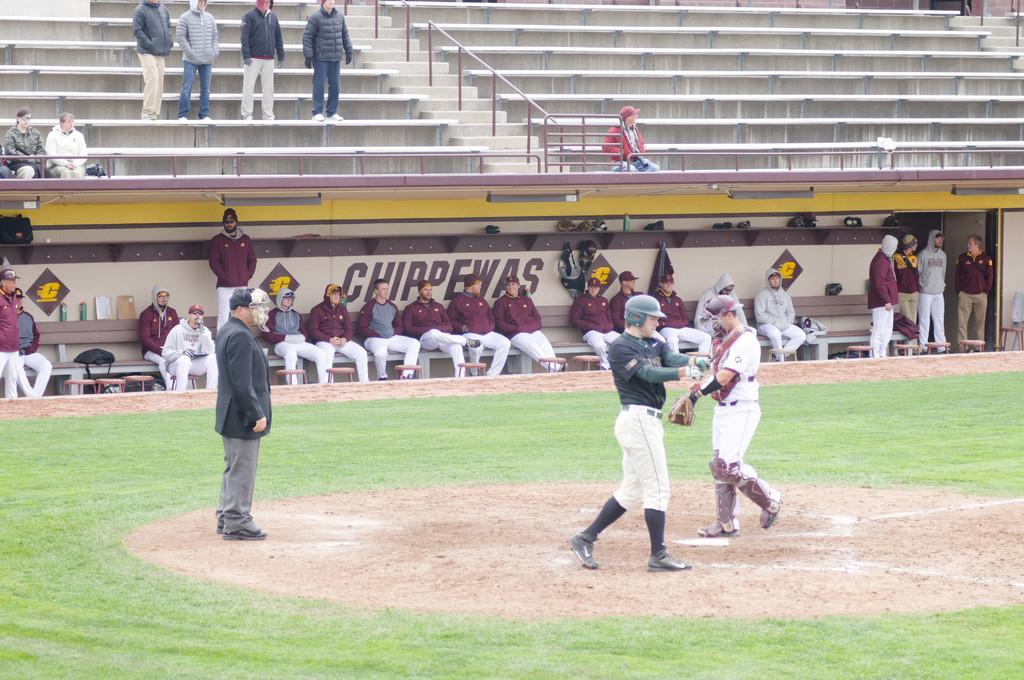<image>
Relay a brief, clear account of the picture shown. Sports team members sit on a bench in front of a wall labeled Chippewas. 